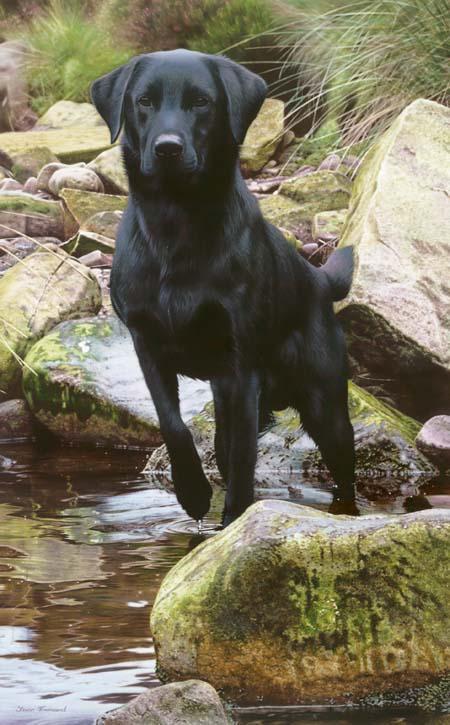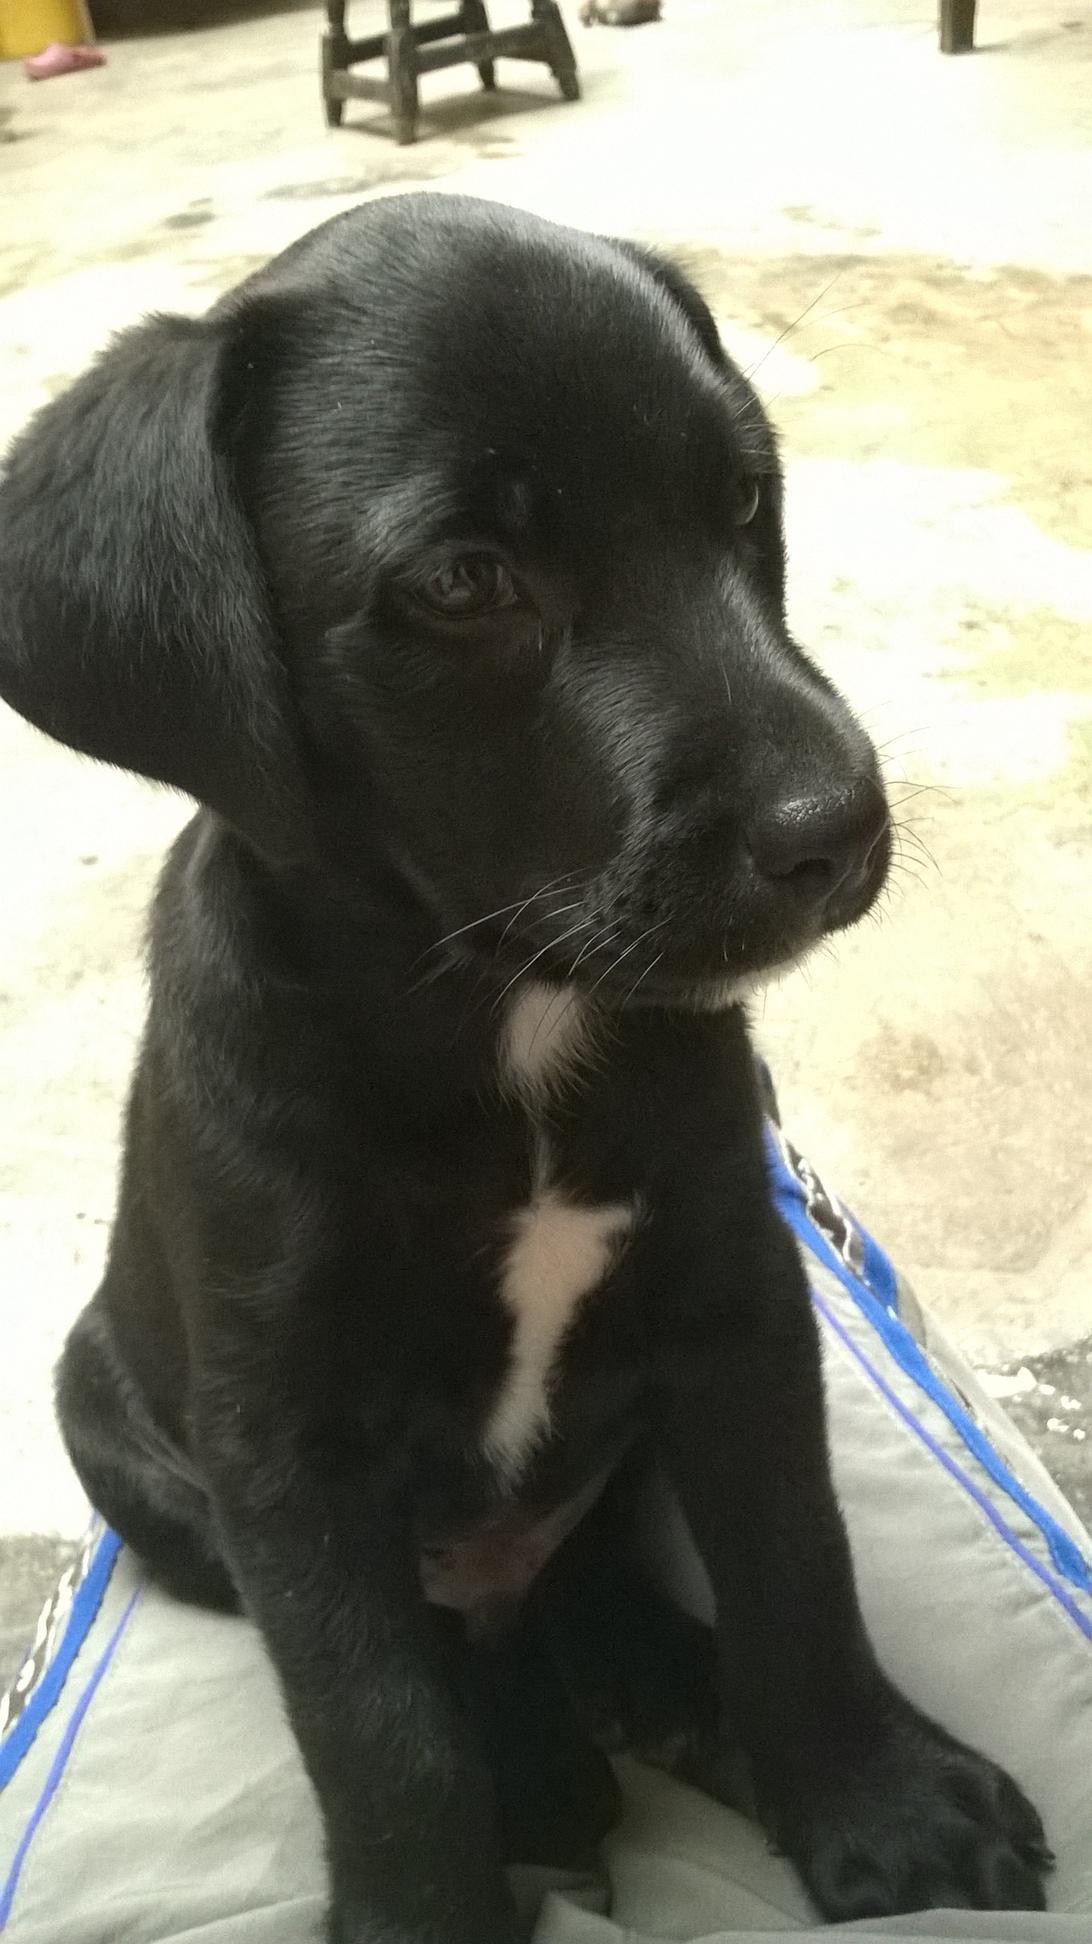The first image is the image on the left, the second image is the image on the right. Examine the images to the left and right. Is the description "There is only one dog that is definitely in a sitting position." accurate? Answer yes or no. Yes. 